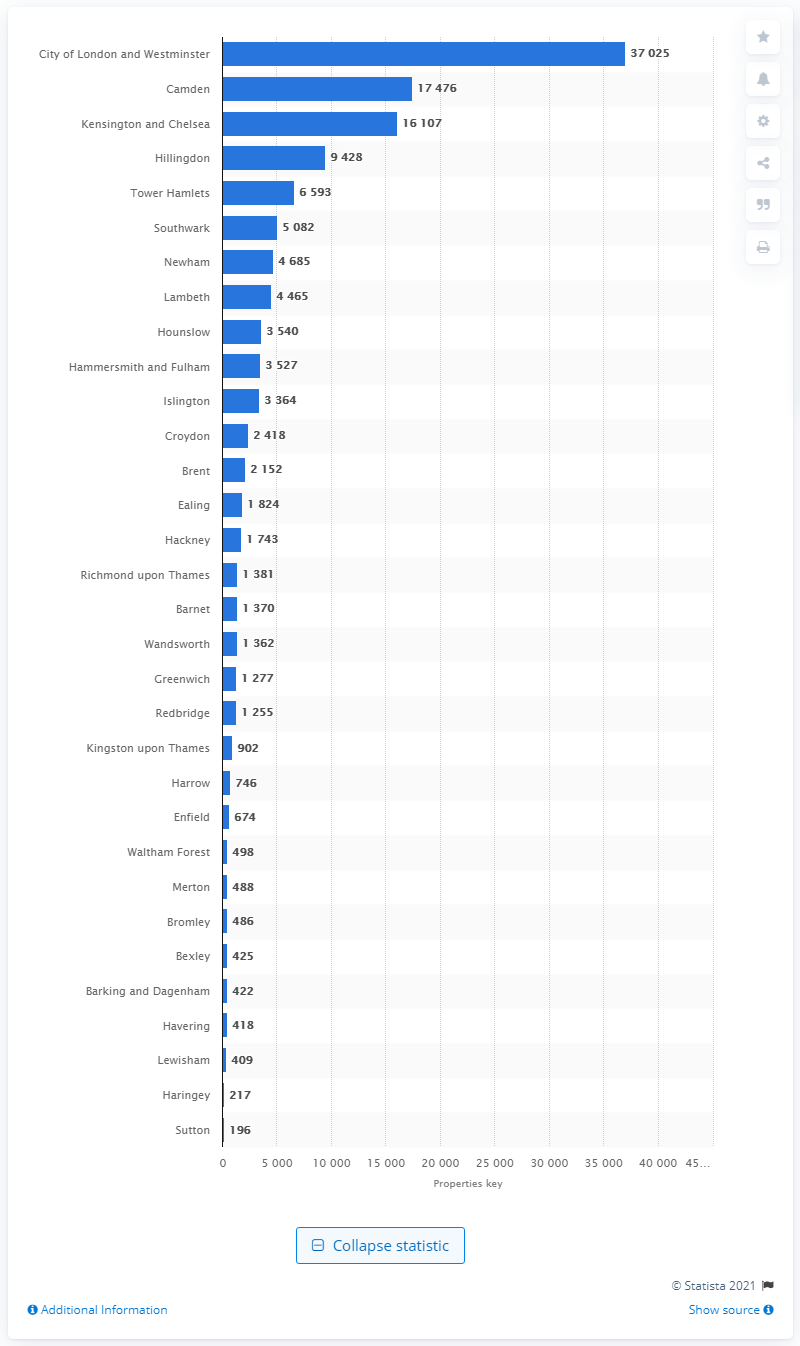Point out several critical features in this image. In the City of London and Westminster, there were a total of 37,025 hotel rooms. According to the data, Camden had the most hotel rooms out of all the boroughs. 